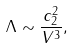<formula> <loc_0><loc_0><loc_500><loc_500>\Lambda \sim \frac { c _ { 2 } ^ { 2 } } { V ^ { 3 } } ,</formula> 